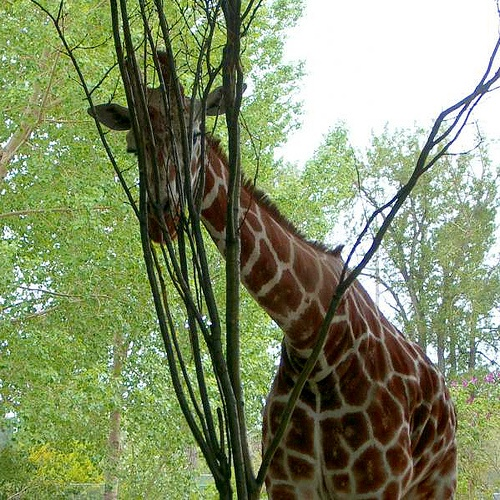Describe the objects in this image and their specific colors. I can see a giraffe in olive, black, maroon, darkgreen, and gray tones in this image. 